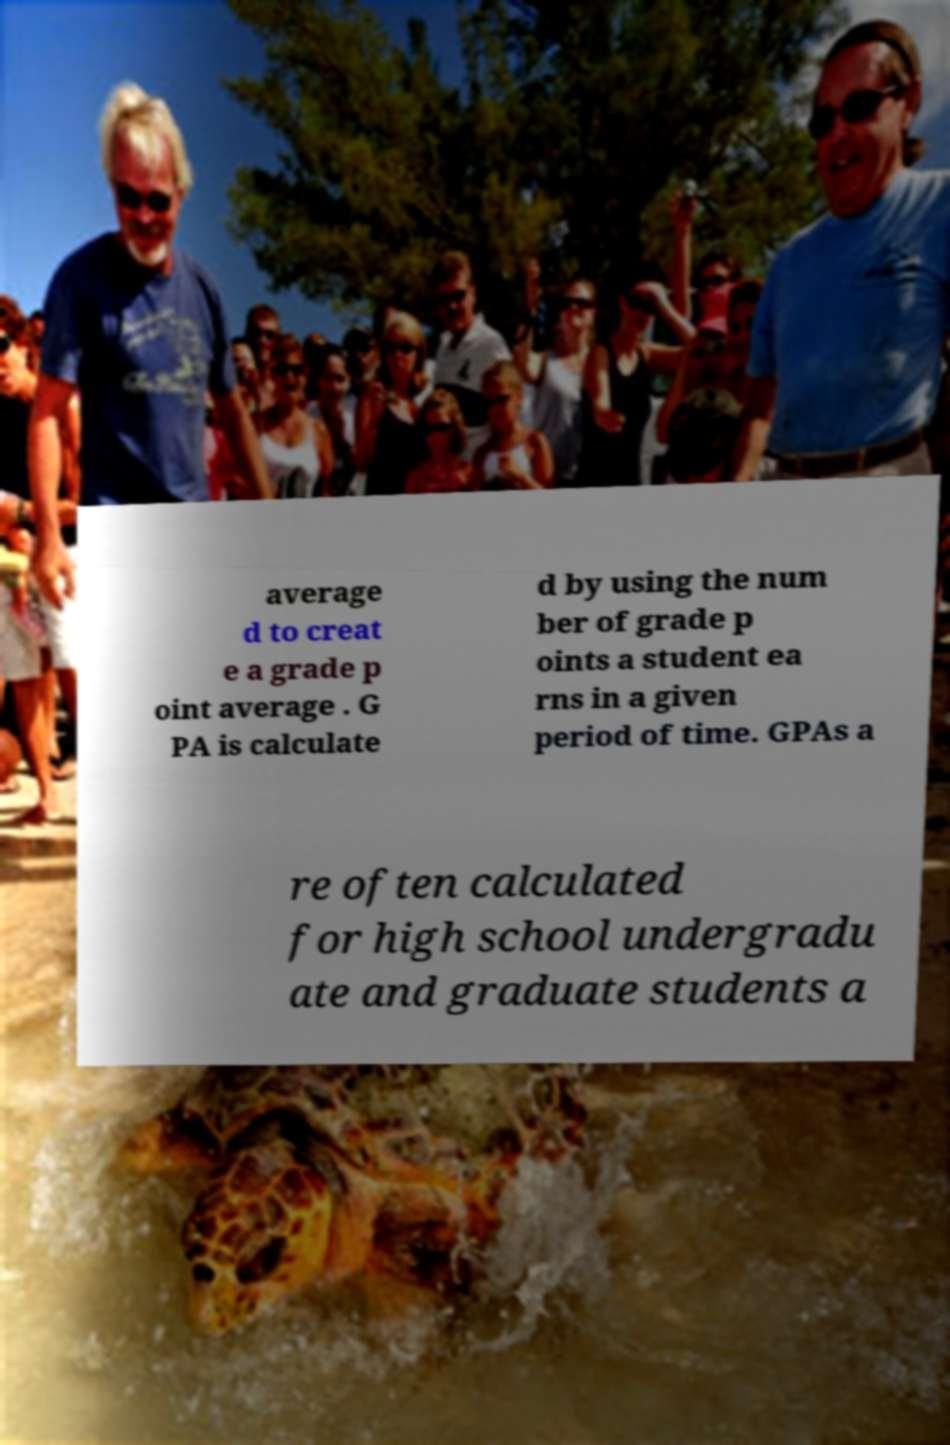Could you extract and type out the text from this image? average d to creat e a grade p oint average . G PA is calculate d by using the num ber of grade p oints a student ea rns in a given period of time. GPAs a re often calculated for high school undergradu ate and graduate students a 